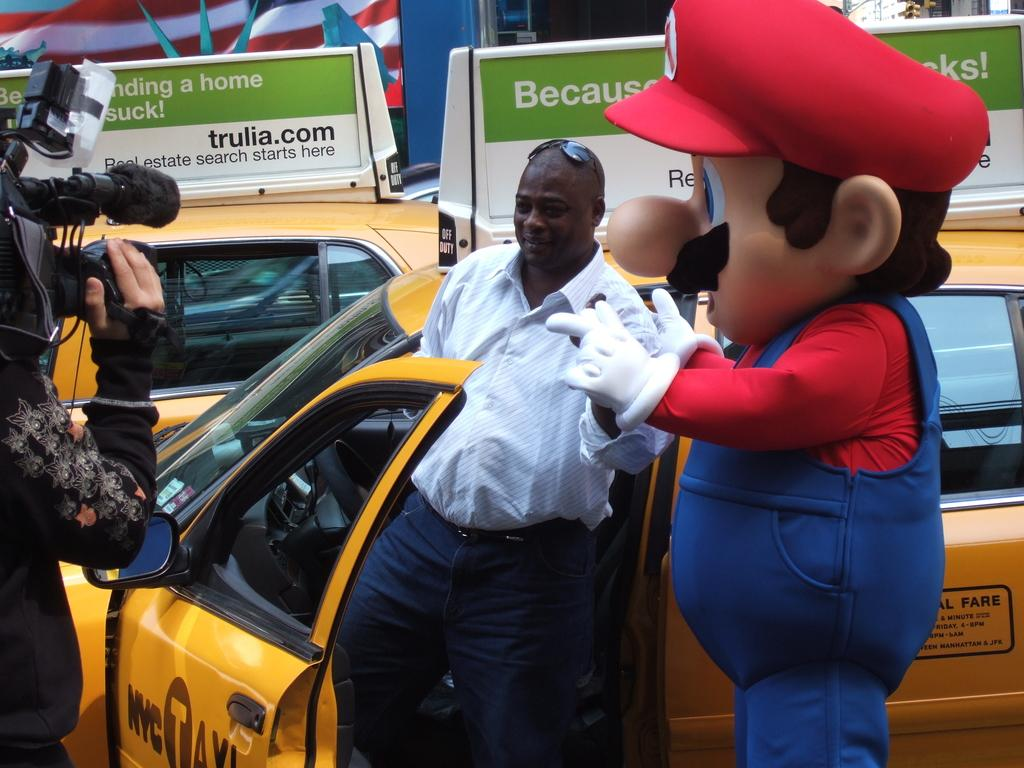<image>
Render a clear and concise summary of the photo. A taxi driver is standing outside his door while a camera operator is filming him beside a man dressed up as Mario 